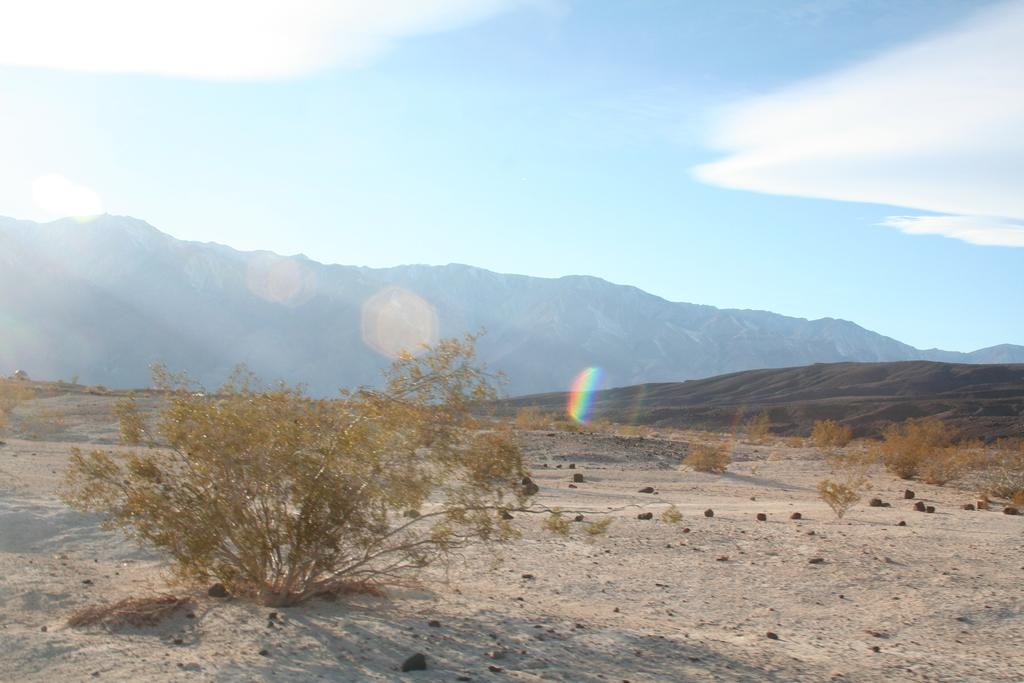What type of terrain is present in the image? There is land in the image. What can be found on the land? There are plants on the land. What can be seen in the distance in the image? There are mountains visible in the background of the image. What else is visible in the background of the image? The sky is visible in the background of the image. How many stitches are required to sew the plants in the image? There are no stitches or sewing involved in the image; the plants are naturally growing on the land. 